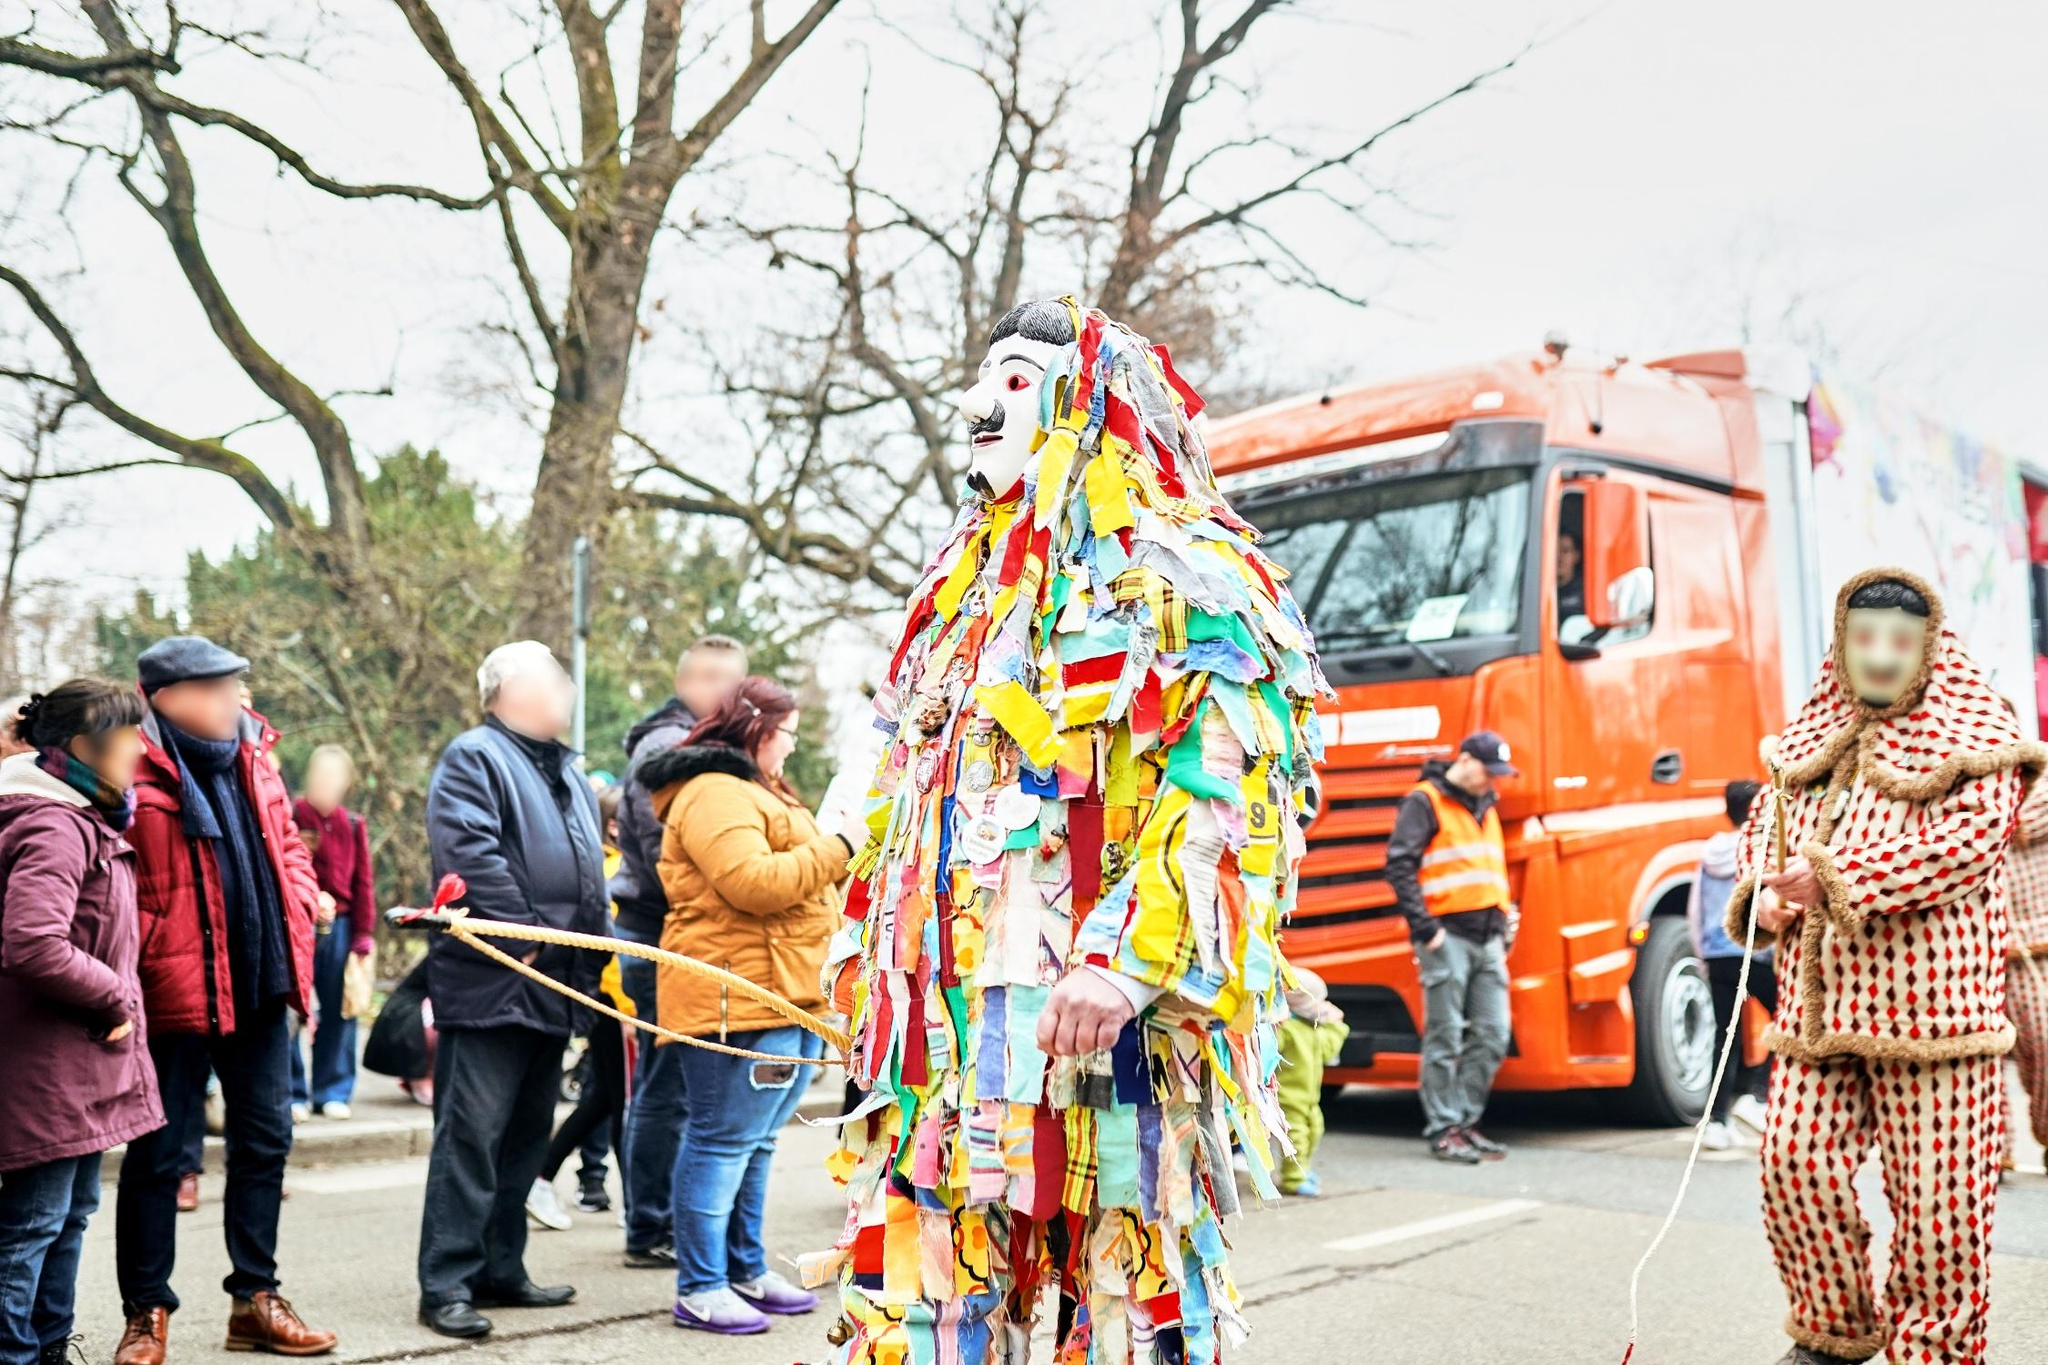What's happening in the scene? The scene captures a lively street parade, characterized by festive costumes and enigmatic mask wear. The individual at the center sports an intricately adorned costume made up of colorful fabric strips in yellow, red, and blue, complemented by a striking white mask with bold black eyes and scarlet lips. They hold a staff draped with multi-colored ribbons, suggesting their role might be central to parade activities. The background reveals more participants in varied attire, contributing to the communal festivities. The setting, amidst a leaf-bare street lined with onlookers and vehicles, further imbues the scene with a communal, celebratory atmosphere typical of cultural or traditional parades. This description points towards a uniquely vibrant community event, possibly with deeper cultural roots and significance, adding layers of meaning to the visual spectacle. 